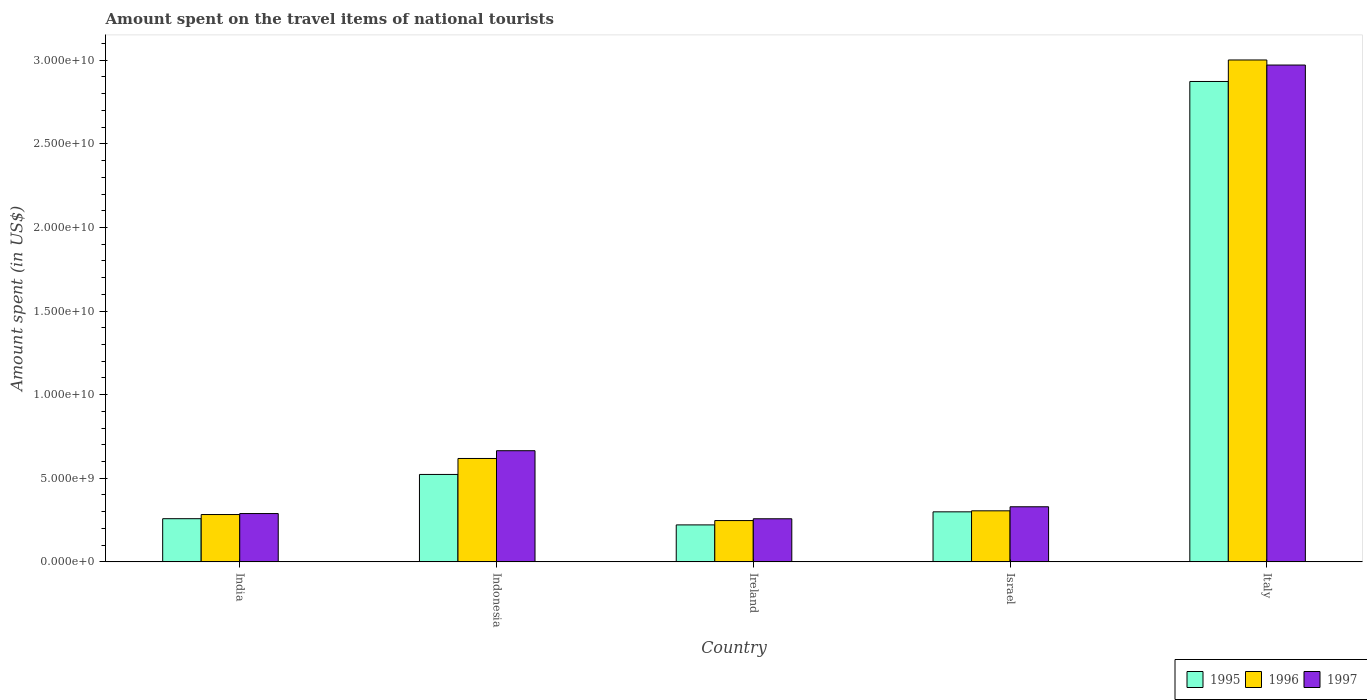How many bars are there on the 4th tick from the left?
Provide a short and direct response. 3. What is the label of the 4th group of bars from the left?
Give a very brief answer. Israel. What is the amount spent on the travel items of national tourists in 1996 in India?
Your response must be concise. 2.83e+09. Across all countries, what is the maximum amount spent on the travel items of national tourists in 1997?
Keep it short and to the point. 2.97e+1. Across all countries, what is the minimum amount spent on the travel items of national tourists in 1995?
Provide a succinct answer. 2.21e+09. In which country was the amount spent on the travel items of national tourists in 1996 minimum?
Keep it short and to the point. Ireland. What is the total amount spent on the travel items of national tourists in 1996 in the graph?
Your answer should be compact. 4.46e+1. What is the difference between the amount spent on the travel items of national tourists in 1997 in Ireland and that in Israel?
Offer a very short reply. -7.17e+08. What is the difference between the amount spent on the travel items of national tourists in 1997 in India and the amount spent on the travel items of national tourists in 1995 in Indonesia?
Keep it short and to the point. -2.34e+09. What is the average amount spent on the travel items of national tourists in 1997 per country?
Provide a succinct answer. 9.02e+09. What is the difference between the amount spent on the travel items of national tourists of/in 1996 and amount spent on the travel items of national tourists of/in 1997 in Italy?
Ensure brevity in your answer.  3.03e+08. What is the ratio of the amount spent on the travel items of national tourists in 1997 in Ireland to that in Israel?
Provide a short and direct response. 0.78. Is the amount spent on the travel items of national tourists in 1996 in India less than that in Indonesia?
Your answer should be compact. Yes. Is the difference between the amount spent on the travel items of national tourists in 1996 in India and Ireland greater than the difference between the amount spent on the travel items of national tourists in 1997 in India and Ireland?
Provide a succinct answer. Yes. What is the difference between the highest and the second highest amount spent on the travel items of national tourists in 1995?
Provide a succinct answer. 2.35e+1. What is the difference between the highest and the lowest amount spent on the travel items of national tourists in 1996?
Provide a succinct answer. 2.75e+1. Is the sum of the amount spent on the travel items of national tourists in 1997 in Indonesia and Israel greater than the maximum amount spent on the travel items of national tourists in 1996 across all countries?
Provide a short and direct response. No. What does the 3rd bar from the left in Indonesia represents?
Ensure brevity in your answer.  1997. Is it the case that in every country, the sum of the amount spent on the travel items of national tourists in 1995 and amount spent on the travel items of national tourists in 1997 is greater than the amount spent on the travel items of national tourists in 1996?
Offer a terse response. Yes. Are all the bars in the graph horizontal?
Your response must be concise. No. What is the difference between two consecutive major ticks on the Y-axis?
Your response must be concise. 5.00e+09. Are the values on the major ticks of Y-axis written in scientific E-notation?
Offer a very short reply. Yes. Does the graph contain grids?
Offer a terse response. No. Where does the legend appear in the graph?
Offer a terse response. Bottom right. How are the legend labels stacked?
Your answer should be very brief. Horizontal. What is the title of the graph?
Give a very brief answer. Amount spent on the travel items of national tourists. Does "2011" appear as one of the legend labels in the graph?
Your response must be concise. No. What is the label or title of the Y-axis?
Ensure brevity in your answer.  Amount spent (in US$). What is the Amount spent (in US$) of 1995 in India?
Provide a short and direct response. 2.58e+09. What is the Amount spent (in US$) of 1996 in India?
Provide a short and direct response. 2.83e+09. What is the Amount spent (in US$) in 1997 in India?
Offer a terse response. 2.89e+09. What is the Amount spent (in US$) of 1995 in Indonesia?
Your answer should be very brief. 5.23e+09. What is the Amount spent (in US$) in 1996 in Indonesia?
Your answer should be very brief. 6.18e+09. What is the Amount spent (in US$) of 1997 in Indonesia?
Your response must be concise. 6.65e+09. What is the Amount spent (in US$) in 1995 in Ireland?
Make the answer very short. 2.21e+09. What is the Amount spent (in US$) in 1996 in Ireland?
Ensure brevity in your answer.  2.47e+09. What is the Amount spent (in US$) of 1997 in Ireland?
Your response must be concise. 2.58e+09. What is the Amount spent (in US$) of 1995 in Israel?
Keep it short and to the point. 2.99e+09. What is the Amount spent (in US$) of 1996 in Israel?
Your answer should be compact. 3.05e+09. What is the Amount spent (in US$) of 1997 in Israel?
Make the answer very short. 3.30e+09. What is the Amount spent (in US$) of 1995 in Italy?
Make the answer very short. 2.87e+1. What is the Amount spent (in US$) in 1996 in Italy?
Offer a terse response. 3.00e+1. What is the Amount spent (in US$) of 1997 in Italy?
Make the answer very short. 2.97e+1. Across all countries, what is the maximum Amount spent (in US$) in 1995?
Give a very brief answer. 2.87e+1. Across all countries, what is the maximum Amount spent (in US$) of 1996?
Provide a short and direct response. 3.00e+1. Across all countries, what is the maximum Amount spent (in US$) in 1997?
Provide a succinct answer. 2.97e+1. Across all countries, what is the minimum Amount spent (in US$) in 1995?
Offer a terse response. 2.21e+09. Across all countries, what is the minimum Amount spent (in US$) in 1996?
Your answer should be compact. 2.47e+09. Across all countries, what is the minimum Amount spent (in US$) of 1997?
Offer a very short reply. 2.58e+09. What is the total Amount spent (in US$) in 1995 in the graph?
Provide a short and direct response. 4.17e+1. What is the total Amount spent (in US$) in 1996 in the graph?
Provide a succinct answer. 4.46e+1. What is the total Amount spent (in US$) in 1997 in the graph?
Give a very brief answer. 4.51e+1. What is the difference between the Amount spent (in US$) in 1995 in India and that in Indonesia?
Your answer should be very brief. -2.65e+09. What is the difference between the Amount spent (in US$) in 1996 in India and that in Indonesia?
Give a very brief answer. -3.35e+09. What is the difference between the Amount spent (in US$) of 1997 in India and that in Indonesia?
Ensure brevity in your answer.  -3.76e+09. What is the difference between the Amount spent (in US$) of 1995 in India and that in Ireland?
Your answer should be compact. 3.71e+08. What is the difference between the Amount spent (in US$) in 1996 in India and that in Ireland?
Keep it short and to the point. 3.61e+08. What is the difference between the Amount spent (in US$) in 1997 in India and that in Ireland?
Your answer should be very brief. 3.12e+08. What is the difference between the Amount spent (in US$) of 1995 in India and that in Israel?
Your answer should be very brief. -4.11e+08. What is the difference between the Amount spent (in US$) of 1996 in India and that in Israel?
Make the answer very short. -2.22e+08. What is the difference between the Amount spent (in US$) of 1997 in India and that in Israel?
Give a very brief answer. -4.05e+08. What is the difference between the Amount spent (in US$) in 1995 in India and that in Italy?
Offer a very short reply. -2.61e+1. What is the difference between the Amount spent (in US$) of 1996 in India and that in Italy?
Ensure brevity in your answer.  -2.72e+1. What is the difference between the Amount spent (in US$) in 1997 in India and that in Italy?
Provide a short and direct response. -2.68e+1. What is the difference between the Amount spent (in US$) in 1995 in Indonesia and that in Ireland?
Keep it short and to the point. 3.02e+09. What is the difference between the Amount spent (in US$) of 1996 in Indonesia and that in Ireland?
Ensure brevity in your answer.  3.71e+09. What is the difference between the Amount spent (in US$) of 1997 in Indonesia and that in Ireland?
Ensure brevity in your answer.  4.07e+09. What is the difference between the Amount spent (in US$) of 1995 in Indonesia and that in Israel?
Offer a terse response. 2.24e+09. What is the difference between the Amount spent (in US$) in 1996 in Indonesia and that in Israel?
Provide a succinct answer. 3.13e+09. What is the difference between the Amount spent (in US$) in 1997 in Indonesia and that in Israel?
Give a very brief answer. 3.35e+09. What is the difference between the Amount spent (in US$) in 1995 in Indonesia and that in Italy?
Offer a terse response. -2.35e+1. What is the difference between the Amount spent (in US$) of 1996 in Indonesia and that in Italy?
Your answer should be compact. -2.38e+1. What is the difference between the Amount spent (in US$) in 1997 in Indonesia and that in Italy?
Give a very brief answer. -2.31e+1. What is the difference between the Amount spent (in US$) of 1995 in Ireland and that in Israel?
Provide a succinct answer. -7.82e+08. What is the difference between the Amount spent (in US$) in 1996 in Ireland and that in Israel?
Ensure brevity in your answer.  -5.83e+08. What is the difference between the Amount spent (in US$) of 1997 in Ireland and that in Israel?
Your answer should be compact. -7.17e+08. What is the difference between the Amount spent (in US$) of 1995 in Ireland and that in Italy?
Your answer should be compact. -2.65e+1. What is the difference between the Amount spent (in US$) in 1996 in Ireland and that in Italy?
Provide a short and direct response. -2.75e+1. What is the difference between the Amount spent (in US$) of 1997 in Ireland and that in Italy?
Your answer should be very brief. -2.71e+1. What is the difference between the Amount spent (in US$) in 1995 in Israel and that in Italy?
Your response must be concise. -2.57e+1. What is the difference between the Amount spent (in US$) in 1996 in Israel and that in Italy?
Ensure brevity in your answer.  -2.70e+1. What is the difference between the Amount spent (in US$) of 1997 in Israel and that in Italy?
Your response must be concise. -2.64e+1. What is the difference between the Amount spent (in US$) of 1995 in India and the Amount spent (in US$) of 1996 in Indonesia?
Your answer should be compact. -3.60e+09. What is the difference between the Amount spent (in US$) of 1995 in India and the Amount spent (in US$) of 1997 in Indonesia?
Give a very brief answer. -4.07e+09. What is the difference between the Amount spent (in US$) in 1996 in India and the Amount spent (in US$) in 1997 in Indonesia?
Your answer should be compact. -3.82e+09. What is the difference between the Amount spent (in US$) in 1995 in India and the Amount spent (in US$) in 1996 in Ireland?
Provide a short and direct response. 1.12e+08. What is the difference between the Amount spent (in US$) in 1996 in India and the Amount spent (in US$) in 1997 in Ireland?
Ensure brevity in your answer.  2.53e+08. What is the difference between the Amount spent (in US$) of 1995 in India and the Amount spent (in US$) of 1996 in Israel?
Provide a short and direct response. -4.71e+08. What is the difference between the Amount spent (in US$) of 1995 in India and the Amount spent (in US$) of 1997 in Israel?
Keep it short and to the point. -7.13e+08. What is the difference between the Amount spent (in US$) of 1996 in India and the Amount spent (in US$) of 1997 in Israel?
Your answer should be very brief. -4.64e+08. What is the difference between the Amount spent (in US$) of 1995 in India and the Amount spent (in US$) of 1996 in Italy?
Offer a very short reply. -2.74e+1. What is the difference between the Amount spent (in US$) of 1995 in India and the Amount spent (in US$) of 1997 in Italy?
Give a very brief answer. -2.71e+1. What is the difference between the Amount spent (in US$) of 1996 in India and the Amount spent (in US$) of 1997 in Italy?
Offer a very short reply. -2.69e+1. What is the difference between the Amount spent (in US$) in 1995 in Indonesia and the Amount spent (in US$) in 1996 in Ireland?
Your answer should be very brief. 2.76e+09. What is the difference between the Amount spent (in US$) in 1995 in Indonesia and the Amount spent (in US$) in 1997 in Ireland?
Offer a terse response. 2.65e+09. What is the difference between the Amount spent (in US$) of 1996 in Indonesia and the Amount spent (in US$) of 1997 in Ireland?
Make the answer very short. 3.61e+09. What is the difference between the Amount spent (in US$) of 1995 in Indonesia and the Amount spent (in US$) of 1996 in Israel?
Provide a succinct answer. 2.18e+09. What is the difference between the Amount spent (in US$) of 1995 in Indonesia and the Amount spent (in US$) of 1997 in Israel?
Make the answer very short. 1.93e+09. What is the difference between the Amount spent (in US$) of 1996 in Indonesia and the Amount spent (in US$) of 1997 in Israel?
Offer a terse response. 2.89e+09. What is the difference between the Amount spent (in US$) in 1995 in Indonesia and the Amount spent (in US$) in 1996 in Italy?
Your answer should be very brief. -2.48e+1. What is the difference between the Amount spent (in US$) of 1995 in Indonesia and the Amount spent (in US$) of 1997 in Italy?
Your answer should be compact. -2.45e+1. What is the difference between the Amount spent (in US$) in 1996 in Indonesia and the Amount spent (in US$) in 1997 in Italy?
Ensure brevity in your answer.  -2.35e+1. What is the difference between the Amount spent (in US$) in 1995 in Ireland and the Amount spent (in US$) in 1996 in Israel?
Your answer should be compact. -8.42e+08. What is the difference between the Amount spent (in US$) of 1995 in Ireland and the Amount spent (in US$) of 1997 in Israel?
Make the answer very short. -1.08e+09. What is the difference between the Amount spent (in US$) in 1996 in Ireland and the Amount spent (in US$) in 1997 in Israel?
Offer a very short reply. -8.25e+08. What is the difference between the Amount spent (in US$) in 1995 in Ireland and the Amount spent (in US$) in 1996 in Italy?
Offer a very short reply. -2.78e+1. What is the difference between the Amount spent (in US$) of 1995 in Ireland and the Amount spent (in US$) of 1997 in Italy?
Make the answer very short. -2.75e+1. What is the difference between the Amount spent (in US$) in 1996 in Ireland and the Amount spent (in US$) in 1997 in Italy?
Your response must be concise. -2.72e+1. What is the difference between the Amount spent (in US$) of 1995 in Israel and the Amount spent (in US$) of 1996 in Italy?
Offer a very short reply. -2.70e+1. What is the difference between the Amount spent (in US$) in 1995 in Israel and the Amount spent (in US$) in 1997 in Italy?
Provide a succinct answer. -2.67e+1. What is the difference between the Amount spent (in US$) in 1996 in Israel and the Amount spent (in US$) in 1997 in Italy?
Your answer should be compact. -2.67e+1. What is the average Amount spent (in US$) of 1995 per country?
Offer a terse response. 8.35e+09. What is the average Amount spent (in US$) in 1996 per country?
Make the answer very short. 8.91e+09. What is the average Amount spent (in US$) in 1997 per country?
Offer a very short reply. 9.02e+09. What is the difference between the Amount spent (in US$) in 1995 and Amount spent (in US$) in 1996 in India?
Make the answer very short. -2.49e+08. What is the difference between the Amount spent (in US$) in 1995 and Amount spent (in US$) in 1997 in India?
Ensure brevity in your answer.  -3.08e+08. What is the difference between the Amount spent (in US$) in 1996 and Amount spent (in US$) in 1997 in India?
Your response must be concise. -5.90e+07. What is the difference between the Amount spent (in US$) of 1995 and Amount spent (in US$) of 1996 in Indonesia?
Keep it short and to the point. -9.55e+08. What is the difference between the Amount spent (in US$) in 1995 and Amount spent (in US$) in 1997 in Indonesia?
Keep it short and to the point. -1.42e+09. What is the difference between the Amount spent (in US$) in 1996 and Amount spent (in US$) in 1997 in Indonesia?
Your answer should be compact. -4.64e+08. What is the difference between the Amount spent (in US$) in 1995 and Amount spent (in US$) in 1996 in Ireland?
Offer a very short reply. -2.59e+08. What is the difference between the Amount spent (in US$) in 1995 and Amount spent (in US$) in 1997 in Ireland?
Your answer should be compact. -3.67e+08. What is the difference between the Amount spent (in US$) in 1996 and Amount spent (in US$) in 1997 in Ireland?
Provide a succinct answer. -1.08e+08. What is the difference between the Amount spent (in US$) in 1995 and Amount spent (in US$) in 1996 in Israel?
Your answer should be very brief. -6.00e+07. What is the difference between the Amount spent (in US$) of 1995 and Amount spent (in US$) of 1997 in Israel?
Offer a terse response. -3.02e+08. What is the difference between the Amount spent (in US$) in 1996 and Amount spent (in US$) in 1997 in Israel?
Your answer should be compact. -2.42e+08. What is the difference between the Amount spent (in US$) in 1995 and Amount spent (in US$) in 1996 in Italy?
Your answer should be compact. -1.29e+09. What is the difference between the Amount spent (in US$) in 1995 and Amount spent (in US$) in 1997 in Italy?
Ensure brevity in your answer.  -9.83e+08. What is the difference between the Amount spent (in US$) of 1996 and Amount spent (in US$) of 1997 in Italy?
Give a very brief answer. 3.03e+08. What is the ratio of the Amount spent (in US$) of 1995 in India to that in Indonesia?
Give a very brief answer. 0.49. What is the ratio of the Amount spent (in US$) in 1996 in India to that in Indonesia?
Make the answer very short. 0.46. What is the ratio of the Amount spent (in US$) in 1997 in India to that in Indonesia?
Provide a short and direct response. 0.43. What is the ratio of the Amount spent (in US$) in 1995 in India to that in Ireland?
Offer a terse response. 1.17. What is the ratio of the Amount spent (in US$) of 1996 in India to that in Ireland?
Ensure brevity in your answer.  1.15. What is the ratio of the Amount spent (in US$) of 1997 in India to that in Ireland?
Offer a terse response. 1.12. What is the ratio of the Amount spent (in US$) in 1995 in India to that in Israel?
Give a very brief answer. 0.86. What is the ratio of the Amount spent (in US$) of 1996 in India to that in Israel?
Offer a very short reply. 0.93. What is the ratio of the Amount spent (in US$) in 1997 in India to that in Israel?
Provide a succinct answer. 0.88. What is the ratio of the Amount spent (in US$) in 1995 in India to that in Italy?
Ensure brevity in your answer.  0.09. What is the ratio of the Amount spent (in US$) of 1996 in India to that in Italy?
Your response must be concise. 0.09. What is the ratio of the Amount spent (in US$) of 1997 in India to that in Italy?
Provide a succinct answer. 0.1. What is the ratio of the Amount spent (in US$) of 1995 in Indonesia to that in Ireland?
Offer a very short reply. 2.37. What is the ratio of the Amount spent (in US$) of 1996 in Indonesia to that in Ireland?
Ensure brevity in your answer.  2.5. What is the ratio of the Amount spent (in US$) in 1997 in Indonesia to that in Ireland?
Keep it short and to the point. 2.58. What is the ratio of the Amount spent (in US$) of 1995 in Indonesia to that in Israel?
Provide a short and direct response. 1.75. What is the ratio of the Amount spent (in US$) in 1996 in Indonesia to that in Israel?
Make the answer very short. 2.03. What is the ratio of the Amount spent (in US$) of 1997 in Indonesia to that in Israel?
Your answer should be very brief. 2.02. What is the ratio of the Amount spent (in US$) in 1995 in Indonesia to that in Italy?
Make the answer very short. 0.18. What is the ratio of the Amount spent (in US$) of 1996 in Indonesia to that in Italy?
Keep it short and to the point. 0.21. What is the ratio of the Amount spent (in US$) in 1997 in Indonesia to that in Italy?
Provide a short and direct response. 0.22. What is the ratio of the Amount spent (in US$) of 1995 in Ireland to that in Israel?
Offer a very short reply. 0.74. What is the ratio of the Amount spent (in US$) in 1996 in Ireland to that in Israel?
Provide a short and direct response. 0.81. What is the ratio of the Amount spent (in US$) in 1997 in Ireland to that in Israel?
Offer a very short reply. 0.78. What is the ratio of the Amount spent (in US$) in 1995 in Ireland to that in Italy?
Your answer should be compact. 0.08. What is the ratio of the Amount spent (in US$) of 1996 in Ireland to that in Italy?
Offer a very short reply. 0.08. What is the ratio of the Amount spent (in US$) in 1997 in Ireland to that in Italy?
Offer a very short reply. 0.09. What is the ratio of the Amount spent (in US$) in 1995 in Israel to that in Italy?
Provide a short and direct response. 0.1. What is the ratio of the Amount spent (in US$) of 1996 in Israel to that in Italy?
Your answer should be very brief. 0.1. What is the ratio of the Amount spent (in US$) in 1997 in Israel to that in Italy?
Keep it short and to the point. 0.11. What is the difference between the highest and the second highest Amount spent (in US$) in 1995?
Offer a very short reply. 2.35e+1. What is the difference between the highest and the second highest Amount spent (in US$) in 1996?
Your answer should be compact. 2.38e+1. What is the difference between the highest and the second highest Amount spent (in US$) of 1997?
Offer a terse response. 2.31e+1. What is the difference between the highest and the lowest Amount spent (in US$) of 1995?
Offer a terse response. 2.65e+1. What is the difference between the highest and the lowest Amount spent (in US$) in 1996?
Provide a short and direct response. 2.75e+1. What is the difference between the highest and the lowest Amount spent (in US$) in 1997?
Ensure brevity in your answer.  2.71e+1. 